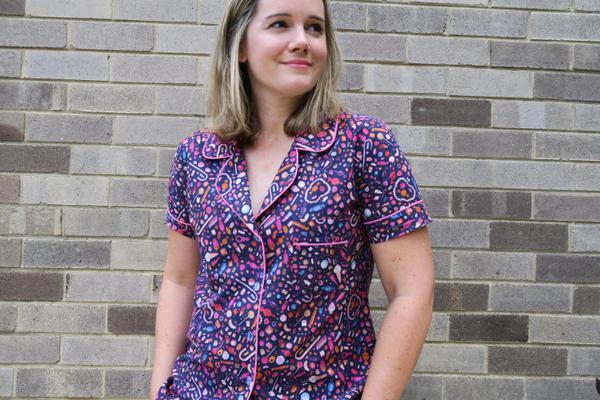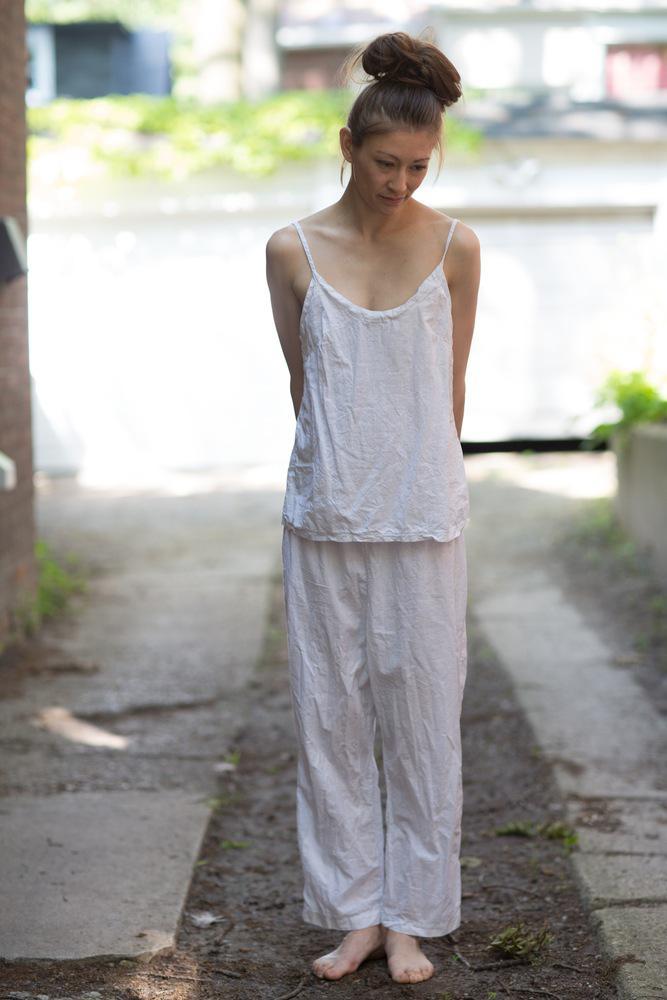The first image is the image on the left, the second image is the image on the right. Considering the images on both sides, is "The right image contains a human wearing a red pajama top while standing outside on a sidewalk." valid? Answer yes or no. No. The first image is the image on the left, the second image is the image on the right. For the images shown, is this caption "The lefthand image shows a pair of pajama-clad models in side-by-side views." true? Answer yes or no. No. 